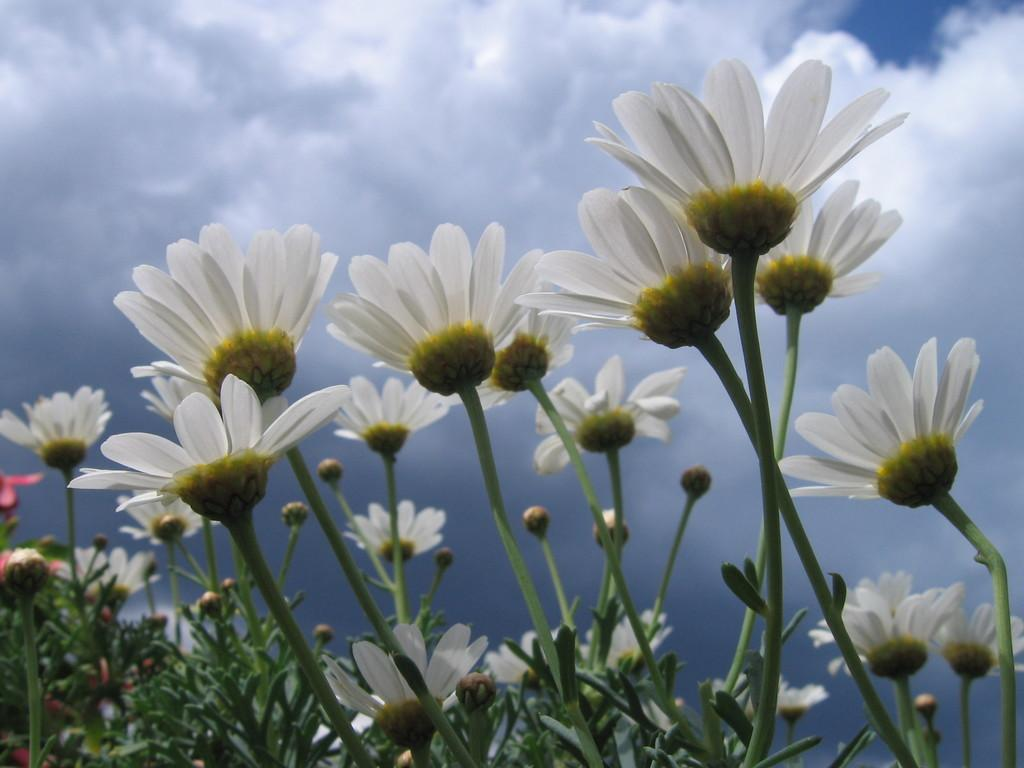What type of living organisms can be seen in the image? Plants can be seen in the image. What specific features can be observed on the plants? The plants have flowers, buds, and leaves. What can be seen in the background of the image? The sky is visible in the background of the image. What type of help can be seen being provided to the plants in the image? There is no indication of help being provided to the plants in the image. The plants appear to be growing naturally. 